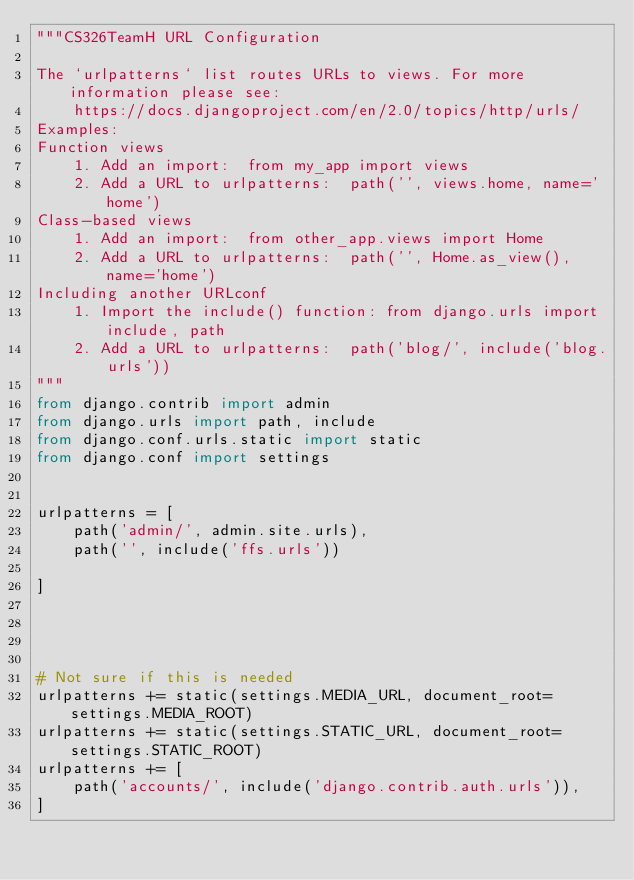Convert code to text. <code><loc_0><loc_0><loc_500><loc_500><_Python_>"""CS326TeamH URL Configuration

The `urlpatterns` list routes URLs to views. For more information please see:
    https://docs.djangoproject.com/en/2.0/topics/http/urls/
Examples:
Function views
    1. Add an import:  from my_app import views
    2. Add a URL to urlpatterns:  path('', views.home, name='home')
Class-based views
    1. Add an import:  from other_app.views import Home
    2. Add a URL to urlpatterns:  path('', Home.as_view(), name='home')
Including another URLconf
    1. Import the include() function: from django.urls import include, path
    2. Add a URL to urlpatterns:  path('blog/', include('blog.urls'))
"""
from django.contrib import admin
from django.urls import path, include
from django.conf.urls.static import static
from django.conf import settings


urlpatterns = [
    path('admin/', admin.site.urls),
    path('', include('ffs.urls'))

]




# Not sure if this is needed
urlpatterns += static(settings.MEDIA_URL, document_root=settings.MEDIA_ROOT)
urlpatterns += static(settings.STATIC_URL, document_root=settings.STATIC_ROOT)
urlpatterns += [
    path('accounts/', include('django.contrib.auth.urls')),
]

</code> 